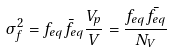Convert formula to latex. <formula><loc_0><loc_0><loc_500><loc_500>\sigma ^ { 2 } _ { f } = f _ { e q } \bar { f } _ { e q } \frac { V _ { p } } { V } = \frac { f _ { e q } \bar { f _ { e q } } } { N _ { V } }</formula> 